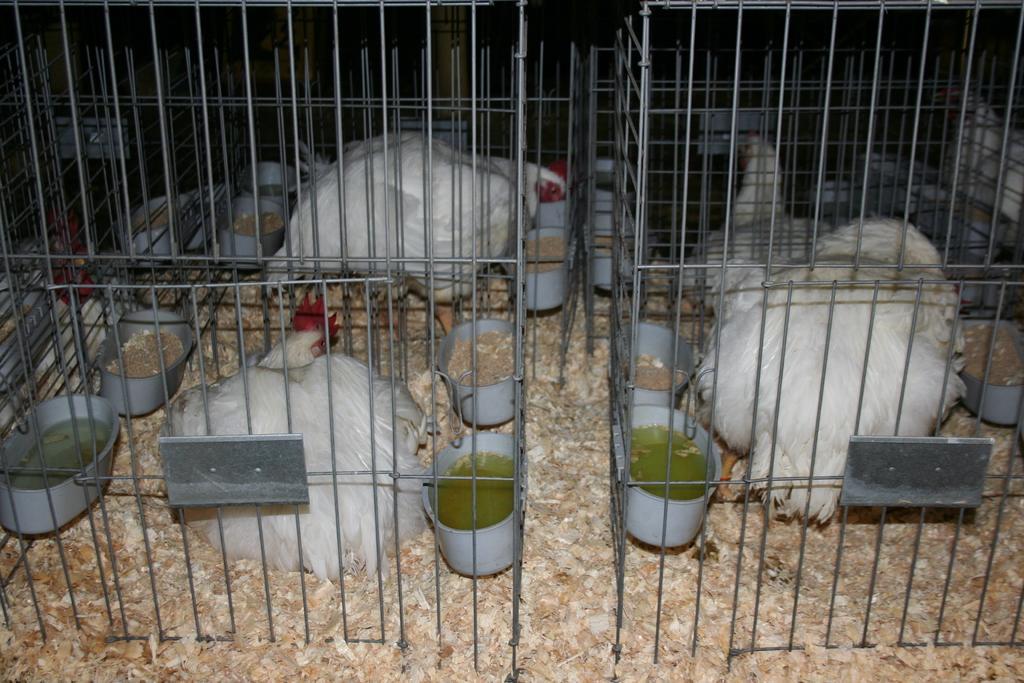Describe this image in one or two sentences. There are white color hens are present in a cage as we can see in the middle of this image. We can see there are some food and water containers. 